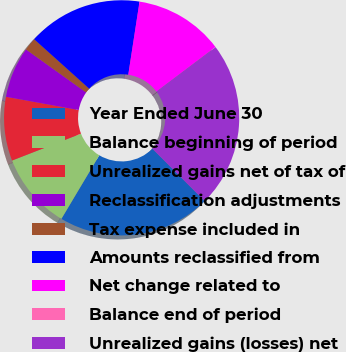Convert chart. <chart><loc_0><loc_0><loc_500><loc_500><pie_chart><fcel>Year Ended June 30<fcel>Balance beginning of period<fcel>Unrealized gains net of tax of<fcel>Reclassification adjustments<fcel>Tax expense included in<fcel>Amounts reclassified from<fcel>Net change related to<fcel>Balance end of period<fcel>Unrealized gains (losses) net<nl><fcel>21.04%<fcel>10.53%<fcel>8.78%<fcel>7.02%<fcel>1.77%<fcel>15.78%<fcel>12.28%<fcel>0.02%<fcel>22.79%<nl></chart> 